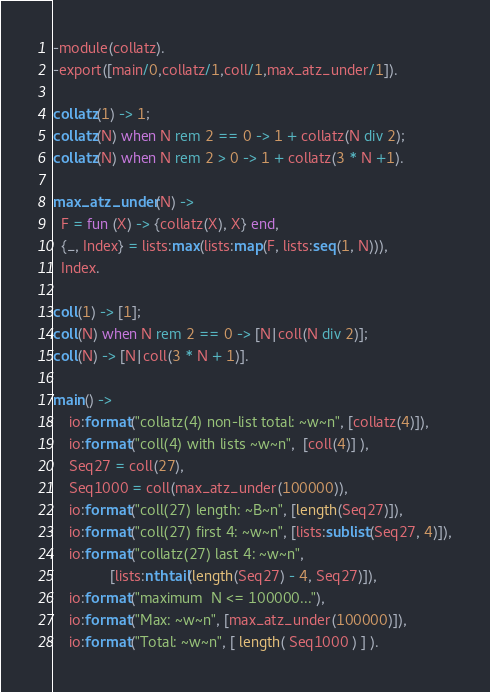Convert code to text. <code><loc_0><loc_0><loc_500><loc_500><_Erlang_>-module(collatz).
-export([main/0,collatz/1,coll/1,max_atz_under/1]).

collatz(1) -> 1;
collatz(N) when N rem 2 == 0 -> 1 + collatz(N div 2);
collatz(N) when N rem 2 > 0 -> 1 + collatz(3 * N +1).

max_atz_under(N) ->
  F = fun (X) -> {collatz(X), X} end,
  {_, Index} = lists:max(lists:map(F, lists:seq(1, N))),
  Index.

coll(1) -> [1];
coll(N) when N rem 2 == 0 -> [N|coll(N div 2)];
coll(N) -> [N|coll(3 * N + 1)].

main() ->
    io:format("collatz(4) non-list total: ~w~n", [collatz(4)]),
    io:format("coll(4) with lists ~w~n",  [coll(4)] ),
    Seq27 = coll(27),
    Seq1000 = coll(max_atz_under(100000)),
    io:format("coll(27) length: ~B~n", [length(Seq27)]),
    io:format("coll(27) first 4: ~w~n", [lists:sublist(Seq27, 4)]),
    io:format("collatz(27) last 4: ~w~n",
              [lists:nthtail(length(Seq27) - 4, Seq27)]),
    io:format("maximum  N <= 100000..."),
    io:format("Max: ~w~n", [max_atz_under(100000)]),
    io:format("Total: ~w~n", [ length( Seq1000 ) ] ).
</code> 